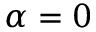<formula> <loc_0><loc_0><loc_500><loc_500>\alpha = 0</formula> 